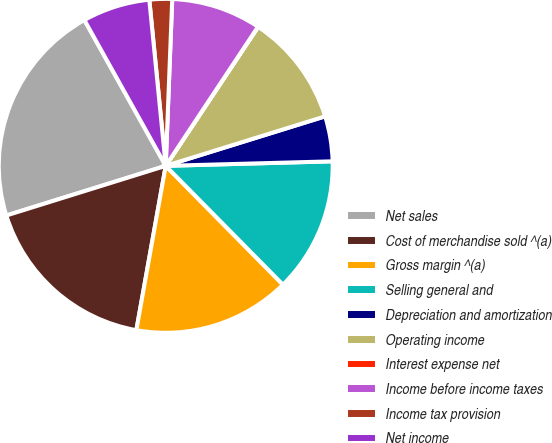Convert chart to OTSL. <chart><loc_0><loc_0><loc_500><loc_500><pie_chart><fcel>Net sales<fcel>Cost of merchandise sold ^(a)<fcel>Gross margin ^(a)<fcel>Selling general and<fcel>Depreciation and amortization<fcel>Operating income<fcel>Interest expense net<fcel>Income before income taxes<fcel>Income tax provision<fcel>Net income<nl><fcel>21.71%<fcel>17.38%<fcel>15.21%<fcel>13.04%<fcel>4.36%<fcel>10.87%<fcel>0.02%<fcel>8.7%<fcel>2.19%<fcel>6.53%<nl></chart> 